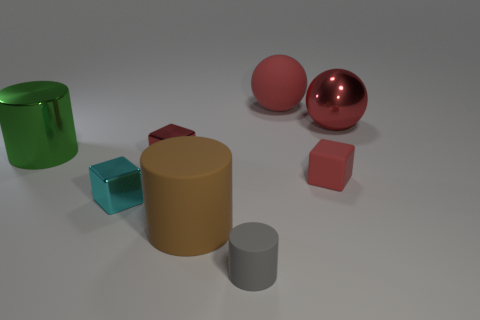Can you identify all the geometric shapes present in the image? Certainly! The image showcases a variety of geometric shapes: there are two cylinders of different sizes, a sphere, a cube, and a rectangular prism. The larger cylinder has a reflective metallic surface, and the smaller one appears matte. The sphere also seems to have a polished metallic finish, while the cube and the rectangular prism exhibit matte surfaces. 